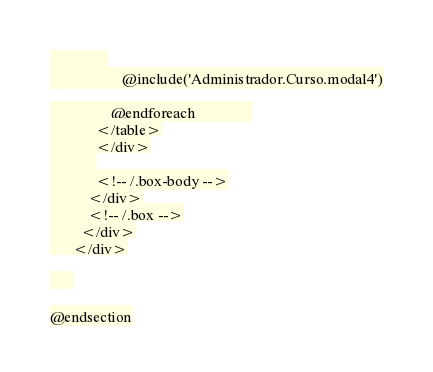<code> <loc_0><loc_0><loc_500><loc_500><_PHP_>               
                   @include('Administrador.Curso.modal4')

                @endforeach               
            </table>
            </div>
            
            <!-- /.box-body -->
          </div>
          <!-- /.box -->
        </div>
      </div>

      

@endsection</code> 